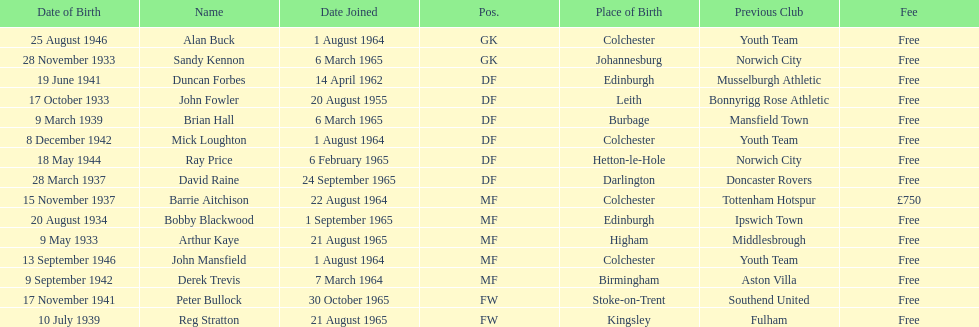Name the player whose fee was not free. Barrie Aitchison. 